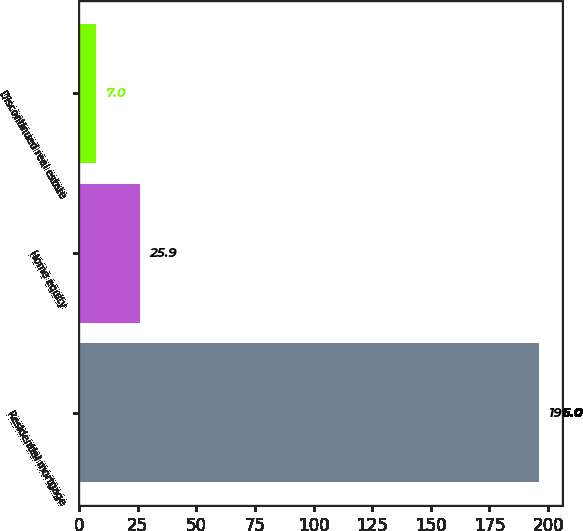<chart> <loc_0><loc_0><loc_500><loc_500><bar_chart><fcel>Residential mortgage<fcel>Home equity<fcel>Discontinued real estate<nl><fcel>196<fcel>25.9<fcel>7<nl></chart> 